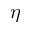<formula> <loc_0><loc_0><loc_500><loc_500>\eta</formula> 